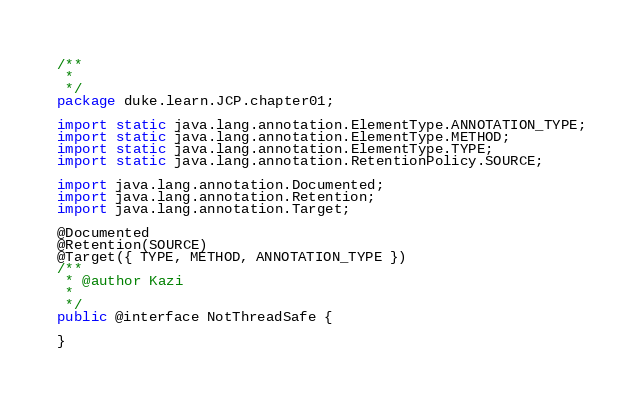<code> <loc_0><loc_0><loc_500><loc_500><_Java_>/**
 * 
 */
package duke.learn.JCP.chapter01;

import static java.lang.annotation.ElementType.ANNOTATION_TYPE;
import static java.lang.annotation.ElementType.METHOD;
import static java.lang.annotation.ElementType.TYPE;
import static java.lang.annotation.RetentionPolicy.SOURCE;

import java.lang.annotation.Documented;
import java.lang.annotation.Retention;
import java.lang.annotation.Target;

@Documented
@Retention(SOURCE)
@Target({ TYPE, METHOD, ANNOTATION_TYPE })
/**
 * @author Kazi
 *
 */
public @interface NotThreadSafe {

}
</code> 